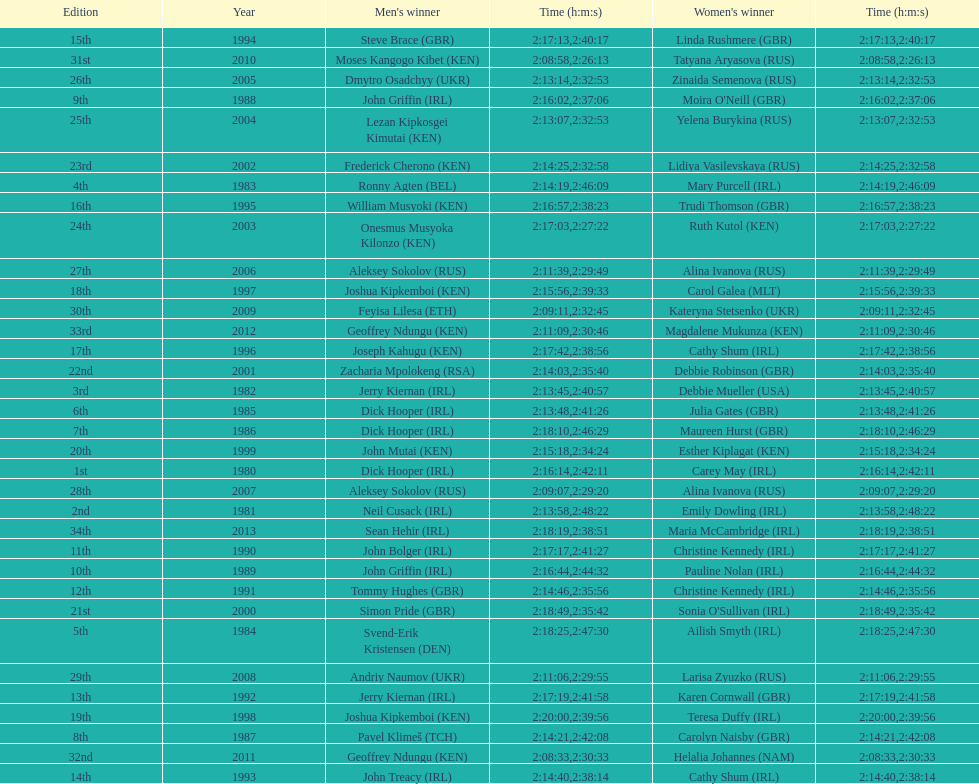How many women's winners are from kenya? 3. 